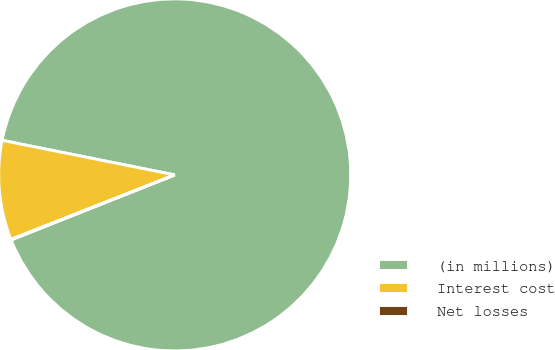Convert chart. <chart><loc_0><loc_0><loc_500><loc_500><pie_chart><fcel>(in millions)<fcel>Interest cost<fcel>Net losses<nl><fcel>90.83%<fcel>9.12%<fcel>0.05%<nl></chart> 